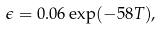Convert formula to latex. <formula><loc_0><loc_0><loc_500><loc_500>\epsilon = 0 . 0 6 \exp ( - 5 8 T ) ,</formula> 